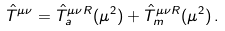Convert formula to latex. <formula><loc_0><loc_0><loc_500><loc_500>\hat { T } ^ { \mu \nu } = \hat { T } ^ { \mu \nu R } _ { a } ( \mu ^ { 2 } ) + \hat { T } ^ { \mu \nu R } _ { m } ( \mu ^ { 2 } ) \, .</formula> 